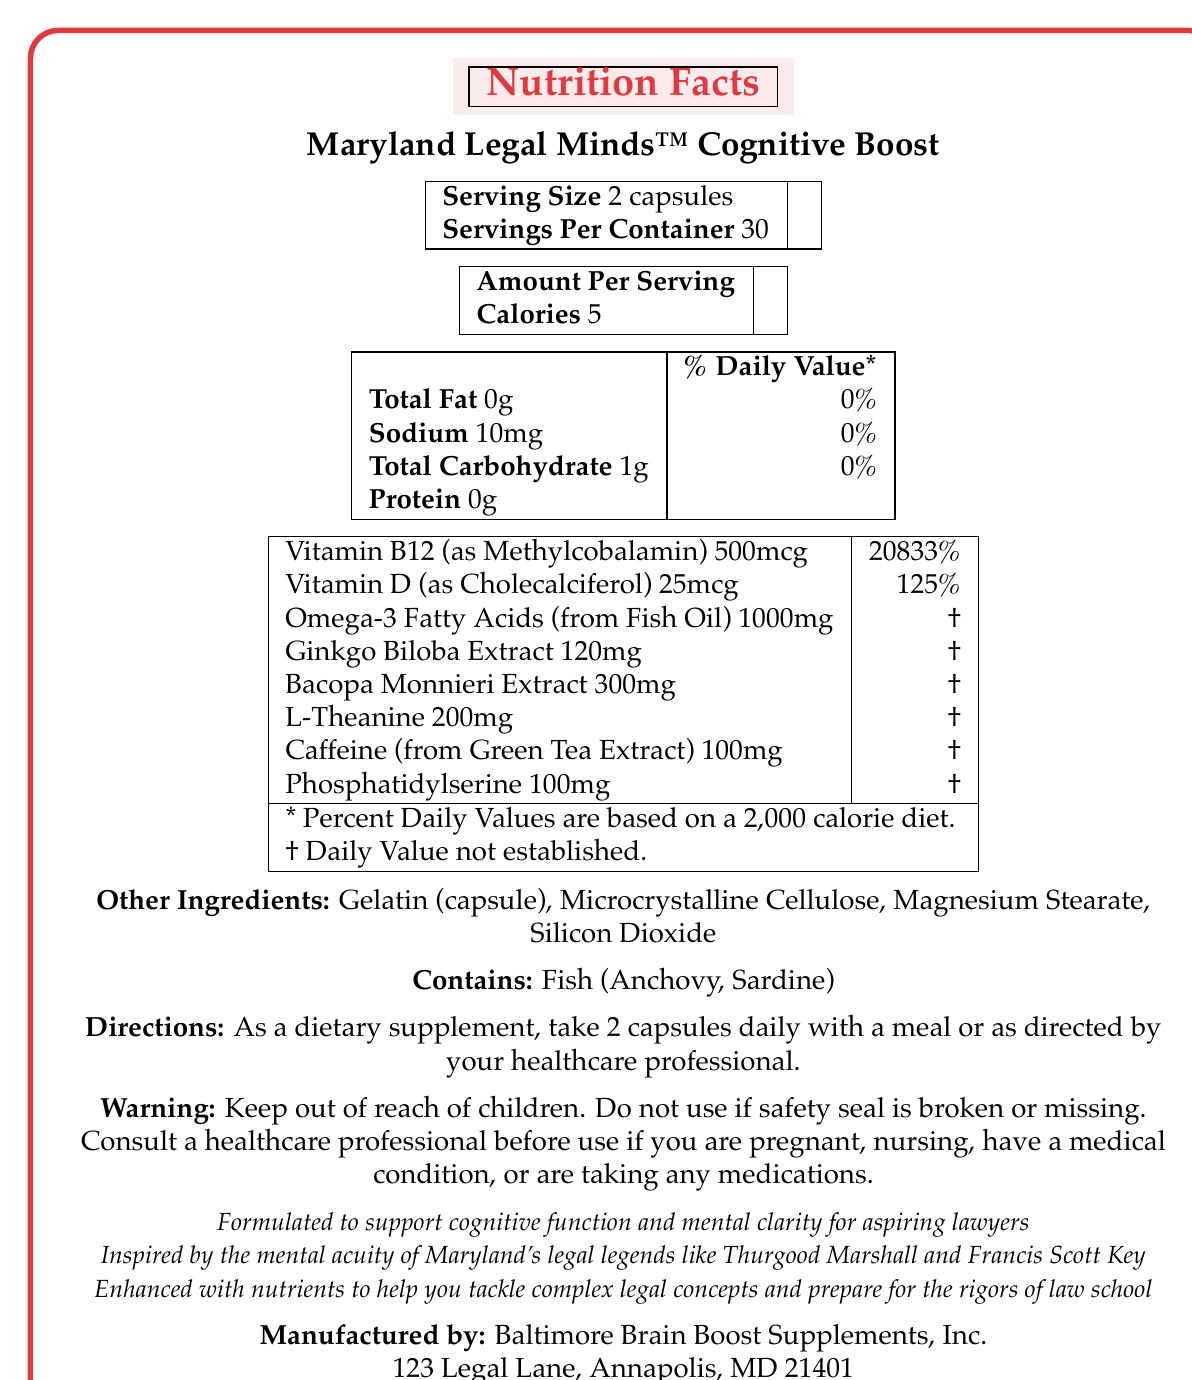what is the serving size for Maryland Legal Minds™ Cognitive Boost? The serving size is clearly mentioned as '2 capsules' in the document.
Answer: 2 capsules how many servings are there per container? The document specifies that there are 30 servings per container.
Answer: 30 what is the amount of Vitamin B12 per serving, and what is its daily value percentage? The document indicates that each serving contains 500mcg of Vitamin B12, which is 20833% of the daily value.
Answer: 500mcg, 20833% what is the amount of calories per serving? The document lists the calories per serving as '5'.
Answer: 5 Which of the following ingredients is included in the supplement?
A. Ginseng
B. Ginkgo Biloba Extract
C. Turmeric
D. Zinc Option B is correct. Ginkgo Biloba Extract is mentioned as one of the ingredients.
Answer: B what are the benefits claimed by Maryland Legal Minds™ Cognitive Boost? The marketing claims include supporting cognitive function and mental clarity, inspiration from Maryland's legal legends, and enhancement with nutrients to tackle complex legal concepts.
Answer: Supports cognitive function and mental clarity, inspired by Maryland's legal legends, enhanced with nutrients for complex legal concepts Does this supplement contain any sources of protein? The document specifies that there is 0g of protein per serving.
Answer: No What are the daily values for Total Fat, Sodium, and Total Carbohydrate? The daily values are listed as 0% for Total Fat, 0% for Sodium, and 0% for Total Carbohydrate.
Answer: Total Fat: 0%, Sodium: 0%, Total Carbohydrate: 0% Which vitamin has a higher daily value percentage, Vitamin B12 or Vitamin D? A. Vitamin B12 B. Vitamin D Vitamin B12 has a higher daily value percentage (20833%) compared to Vitamin D (125%).
Answer: A Does the supplement contain fish allergens? The document clearly mentions that it contains fish (Anchovy, Sardine).
Answer: Yes Can the Vitamin B12 in Maryland Legal Minds™ Cognitive Boost be classified as Methylcobalamin? The document specifies that Vitamin B12 is present as Methylcobalamin.
Answer: Yes Is the Omega-3 Fatty Acids daily value established in the document? The document mentions that the daily value for Omega-3 Fatty Acids is not established.
Answer: No Summarize the main idea of the Maryland Legal Minds™ Cognitive Boost document. The document offers comprehensive information about a vitamin supplement aimed at improving cognitive functions for law students, listing important ingredients, nutritional details, usage directions, and additional warnings and claims about the product's benefits.
Answer: The document provides information about Maryland Legal Minds™ Cognitive Boost, a cognitive supplement designed for aspiring lawyers. It details nutrition facts, serving size, and claims about mental acuity. Key ingredients include Vitamin B12, Vitamin D, Omega-3 Fatty Acids, Ginkgo Biloba Extract, Bacopa Monnieri Extract, L-Theanine, Caffeine, and Phosphatidylserine. The product is claimed to support cognitive function and is inspired by Maryland's legal legends. Warnings and allergen information are also provided. What are the directions for taking the supplement? The directions state to take 2 capsules daily with a meal or follow the guidance of a healthcare professional.
Answer: Take 2 capsules daily with a meal or as directed by your healthcare professional Why should someone consult a healthcare professional before using the supplement? A. If they are pregnant or nursing B. If they have a medical condition C. If they are taking medications D. All of the above All of the above reasons are mentioned as conditions under which one should consult a healthcare professional before using the supplement.
Answer: D which Maryland legal legends inspire this product? The document states that the product is inspired by the mental acuity of Maryland's legal legends like Thurgood Marshall and Francis Scott Key.
Answer: Thurgood Marshall and Francis Scott Key Given the information in the document, what specific health conditions does the supplement treat or cure? The document does not provide any specific information about health conditions it treats or cures, only claims about cognitive support and mental clarity.
Answer: Not enough information 